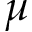Convert formula to latex. <formula><loc_0><loc_0><loc_500><loc_500>\mu</formula> 